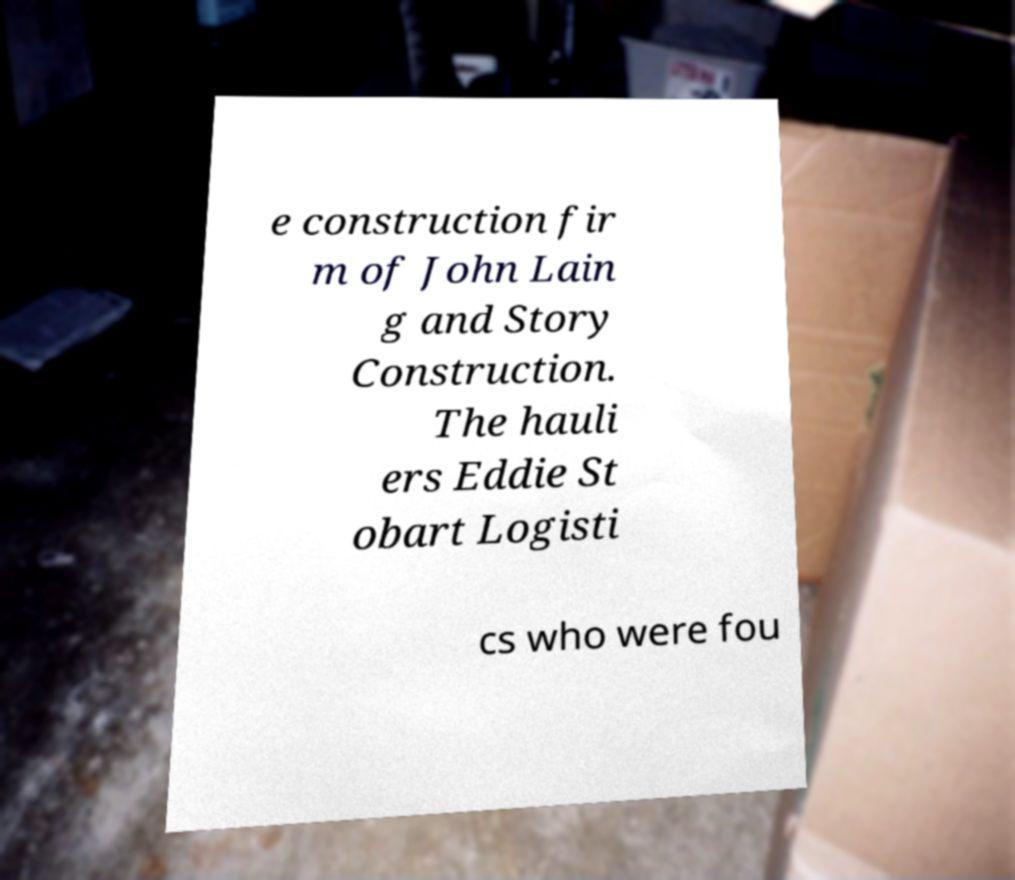For documentation purposes, I need the text within this image transcribed. Could you provide that? e construction fir m of John Lain g and Story Construction. The hauli ers Eddie St obart Logisti cs who were fou 